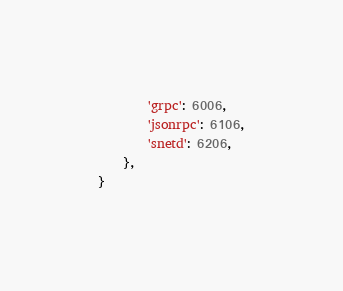<code> <loc_0><loc_0><loc_500><loc_500><_Python_>        'grpc': 6006,
        'jsonrpc': 6106,
        'snetd': 6206,
    },
}</code> 